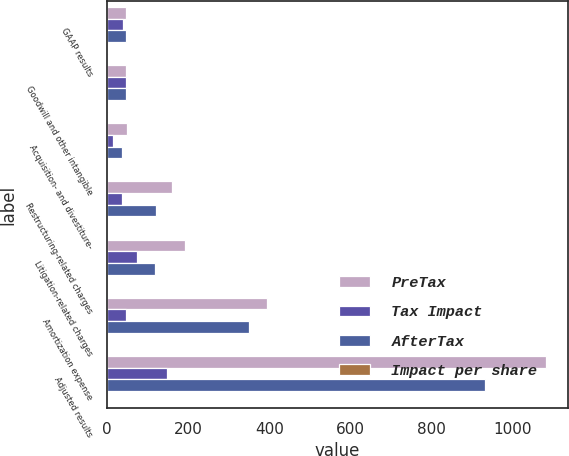Convert chart to OTSL. <chart><loc_0><loc_0><loc_500><loc_500><stacked_bar_chart><ecel><fcel>GAAP results<fcel>Goodwill and other intangible<fcel>Acquisition- and divestiture-<fcel>Restructuring-related charges<fcel>Litigation-related charges<fcel>Amortization expense<fcel>Adjusted results<nl><fcel>PreTax<fcel>46<fcel>46<fcel>50<fcel>160<fcel>192<fcel>395<fcel>1082<nl><fcel>Tax Impact<fcel>39<fcel>46<fcel>14<fcel>38<fcel>74<fcel>46<fcel>149<nl><fcel>AfterTax<fcel>46<fcel>46<fcel>36<fcel>122<fcel>118<fcel>349<fcel>933<nl><fcel>Impact per share<fcel>2.89<fcel>3.15<fcel>0.02<fcel>0.09<fcel>0.08<fcel>0.25<fcel>0.66<nl></chart> 